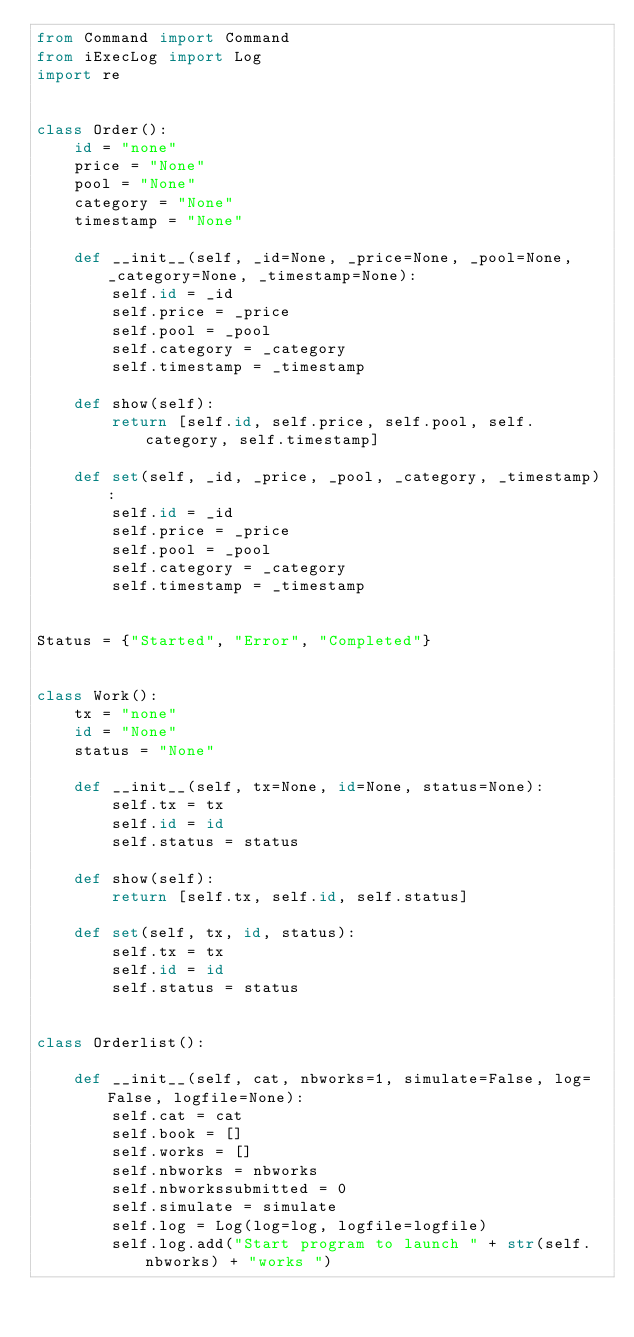<code> <loc_0><loc_0><loc_500><loc_500><_Python_>from Command import Command
from iExecLog import Log
import re


class Order():
    id = "none"
    price = "None"
    pool = "None"
    category = "None"
    timestamp = "None"

    def __init__(self, _id=None, _price=None, _pool=None, _category=None, _timestamp=None):
        self.id = _id
        self.price = _price
        self.pool = _pool
        self.category = _category
        self.timestamp = _timestamp

    def show(self):
        return [self.id, self.price, self.pool, self.category, self.timestamp]

    def set(self, _id, _price, _pool, _category, _timestamp):
        self.id = _id
        self.price = _price
        self.pool = _pool
        self.category = _category
        self.timestamp = _timestamp


Status = {"Started", "Error", "Completed"}


class Work():
    tx = "none"
    id = "None"
    status = "None"

    def __init__(self, tx=None, id=None, status=None):
        self.tx = tx
        self.id = id
        self.status = status

    def show(self):
        return [self.tx, self.id, self.status]

    def set(self, tx, id, status):
        self.tx = tx
        self.id = id
        self.status = status


class Orderlist():

    def __init__(self, cat, nbworks=1, simulate=False, log=False, logfile=None):
        self.cat = cat
        self.book = []
        self.works = []
        self.nbworks = nbworks
        self.nbworkssubmitted = 0
        self.simulate = simulate
        self.log = Log(log=log, logfile=logfile)
        self.log.add("Start program to launch " + str(self.nbworks) + "works ")
</code> 